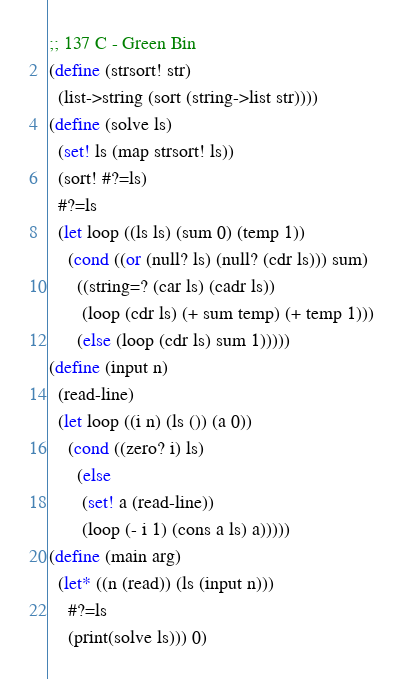<code> <loc_0><loc_0><loc_500><loc_500><_Scheme_>;; 137 C - Green Bin
(define (strsort! str)
  (list->string (sort (string->list str))))
(define (solve ls)
  (set! ls (map strsort! ls))
  (sort! #?=ls)
  #?=ls
  (let loop ((ls ls) (sum 0) (temp 1))
    (cond ((or (null? ls) (null? (cdr ls))) sum)
	  ((string=? (car ls) (cadr ls))
	   (loop (cdr ls) (+ sum temp) (+ temp 1)))
	  (else (loop (cdr ls) sum 1)))))
(define (input n)
  (read-line)
  (let loop ((i n) (ls ()) (a 0))
    (cond ((zero? i) ls)
	  (else
	   (set! a (read-line))
	   (loop (- i 1) (cons a ls) a)))))
(define (main arg)
  (let* ((n (read)) (ls (input n)))
    #?=ls
    (print(solve ls))) 0)
</code> 